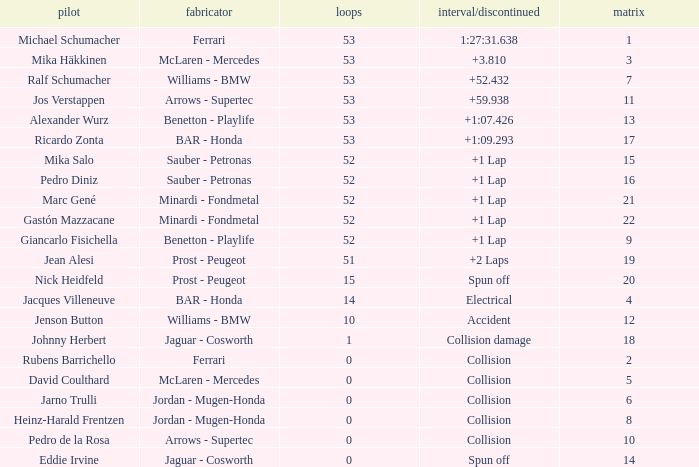Can you give me this table as a dict? {'header': ['pilot', 'fabricator', 'loops', 'interval/discontinued', 'matrix'], 'rows': [['Michael Schumacher', 'Ferrari', '53', '1:27:31.638', '1'], ['Mika Häkkinen', 'McLaren - Mercedes', '53', '+3.810', '3'], ['Ralf Schumacher', 'Williams - BMW', '53', '+52.432', '7'], ['Jos Verstappen', 'Arrows - Supertec', '53', '+59.938', '11'], ['Alexander Wurz', 'Benetton - Playlife', '53', '+1:07.426', '13'], ['Ricardo Zonta', 'BAR - Honda', '53', '+1:09.293', '17'], ['Mika Salo', 'Sauber - Petronas', '52', '+1 Lap', '15'], ['Pedro Diniz', 'Sauber - Petronas', '52', '+1 Lap', '16'], ['Marc Gené', 'Minardi - Fondmetal', '52', '+1 Lap', '21'], ['Gastón Mazzacane', 'Minardi - Fondmetal', '52', '+1 Lap', '22'], ['Giancarlo Fisichella', 'Benetton - Playlife', '52', '+1 Lap', '9'], ['Jean Alesi', 'Prost - Peugeot', '51', '+2 Laps', '19'], ['Nick Heidfeld', 'Prost - Peugeot', '15', 'Spun off', '20'], ['Jacques Villeneuve', 'BAR - Honda', '14', 'Electrical', '4'], ['Jenson Button', 'Williams - BMW', '10', 'Accident', '12'], ['Johnny Herbert', 'Jaguar - Cosworth', '1', 'Collision damage', '18'], ['Rubens Barrichello', 'Ferrari', '0', 'Collision', '2'], ['David Coulthard', 'McLaren - Mercedes', '0', 'Collision', '5'], ['Jarno Trulli', 'Jordan - Mugen-Honda', '0', 'Collision', '6'], ['Heinz-Harald Frentzen', 'Jordan - Mugen-Honda', '0', 'Collision', '8'], ['Pedro de la Rosa', 'Arrows - Supertec', '0', 'Collision', '10'], ['Eddie Irvine', 'Jaguar - Cosworth', '0', 'Spun off', '14']]} How many laps did Ricardo Zonta have? 53.0. 